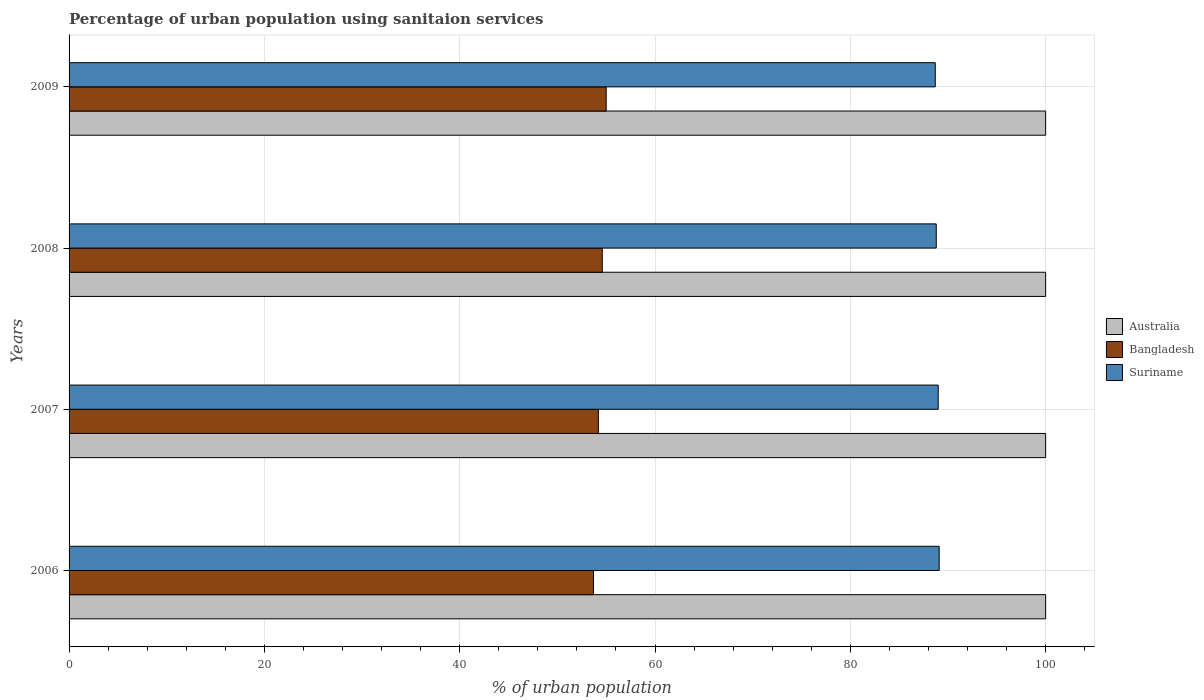How many bars are there on the 1st tick from the top?
Make the answer very short. 3. What is the label of the 4th group of bars from the top?
Offer a terse response. 2006. What is the percentage of urban population using sanitaion services in Bangladesh in 2007?
Offer a very short reply. 54.2. Across all years, what is the maximum percentage of urban population using sanitaion services in Suriname?
Give a very brief answer. 89.1. Across all years, what is the minimum percentage of urban population using sanitaion services in Australia?
Offer a terse response. 100. In which year was the percentage of urban population using sanitaion services in Suriname maximum?
Provide a short and direct response. 2006. In which year was the percentage of urban population using sanitaion services in Australia minimum?
Provide a short and direct response. 2006. What is the total percentage of urban population using sanitaion services in Bangladesh in the graph?
Offer a very short reply. 217.5. What is the difference between the percentage of urban population using sanitaion services in Australia in 2006 and the percentage of urban population using sanitaion services in Suriname in 2009?
Provide a short and direct response. 11.3. In the year 2008, what is the difference between the percentage of urban population using sanitaion services in Suriname and percentage of urban population using sanitaion services in Bangladesh?
Provide a short and direct response. 34.2. What is the ratio of the percentage of urban population using sanitaion services in Bangladesh in 2006 to that in 2007?
Your answer should be compact. 0.99. Is the difference between the percentage of urban population using sanitaion services in Suriname in 2008 and 2009 greater than the difference between the percentage of urban population using sanitaion services in Bangladesh in 2008 and 2009?
Your response must be concise. Yes. What is the difference between the highest and the second highest percentage of urban population using sanitaion services in Bangladesh?
Offer a terse response. 0.4. What is the difference between the highest and the lowest percentage of urban population using sanitaion services in Suriname?
Your response must be concise. 0.4. In how many years, is the percentage of urban population using sanitaion services in Bangladesh greater than the average percentage of urban population using sanitaion services in Bangladesh taken over all years?
Your answer should be compact. 2. What does the 3rd bar from the bottom in 2009 represents?
Offer a very short reply. Suriname. Is it the case that in every year, the sum of the percentage of urban population using sanitaion services in Australia and percentage of urban population using sanitaion services in Suriname is greater than the percentage of urban population using sanitaion services in Bangladesh?
Keep it short and to the point. Yes. How many bars are there?
Your response must be concise. 12. Are all the bars in the graph horizontal?
Offer a very short reply. Yes. Are the values on the major ticks of X-axis written in scientific E-notation?
Make the answer very short. No. Does the graph contain any zero values?
Make the answer very short. No. Where does the legend appear in the graph?
Make the answer very short. Center right. How many legend labels are there?
Offer a very short reply. 3. How are the legend labels stacked?
Your answer should be very brief. Vertical. What is the title of the graph?
Your response must be concise. Percentage of urban population using sanitaion services. Does "Arab World" appear as one of the legend labels in the graph?
Your response must be concise. No. What is the label or title of the X-axis?
Provide a succinct answer. % of urban population. What is the % of urban population of Bangladesh in 2006?
Make the answer very short. 53.7. What is the % of urban population in Suriname in 2006?
Keep it short and to the point. 89.1. What is the % of urban population in Bangladesh in 2007?
Offer a very short reply. 54.2. What is the % of urban population of Suriname in 2007?
Your answer should be compact. 89. What is the % of urban population in Bangladesh in 2008?
Offer a terse response. 54.6. What is the % of urban population of Suriname in 2008?
Your response must be concise. 88.8. What is the % of urban population of Bangladesh in 2009?
Your response must be concise. 55. What is the % of urban population of Suriname in 2009?
Offer a very short reply. 88.7. Across all years, what is the maximum % of urban population in Australia?
Ensure brevity in your answer.  100. Across all years, what is the maximum % of urban population in Bangladesh?
Give a very brief answer. 55. Across all years, what is the maximum % of urban population of Suriname?
Provide a succinct answer. 89.1. Across all years, what is the minimum % of urban population in Australia?
Your response must be concise. 100. Across all years, what is the minimum % of urban population of Bangladesh?
Keep it short and to the point. 53.7. Across all years, what is the minimum % of urban population of Suriname?
Your response must be concise. 88.7. What is the total % of urban population of Bangladesh in the graph?
Ensure brevity in your answer.  217.5. What is the total % of urban population of Suriname in the graph?
Give a very brief answer. 355.6. What is the difference between the % of urban population of Australia in 2006 and that in 2007?
Provide a short and direct response. 0. What is the difference between the % of urban population of Suriname in 2006 and that in 2007?
Offer a very short reply. 0.1. What is the difference between the % of urban population of Australia in 2006 and that in 2008?
Give a very brief answer. 0. What is the difference between the % of urban population in Bangladesh in 2006 and that in 2008?
Ensure brevity in your answer.  -0.9. What is the difference between the % of urban population of Suriname in 2006 and that in 2008?
Ensure brevity in your answer.  0.3. What is the difference between the % of urban population in Australia in 2006 and that in 2009?
Keep it short and to the point. 0. What is the difference between the % of urban population in Australia in 2007 and that in 2008?
Your response must be concise. 0. What is the difference between the % of urban population in Suriname in 2007 and that in 2009?
Offer a very short reply. 0.3. What is the difference between the % of urban population of Bangladesh in 2008 and that in 2009?
Give a very brief answer. -0.4. What is the difference between the % of urban population in Australia in 2006 and the % of urban population in Bangladesh in 2007?
Ensure brevity in your answer.  45.8. What is the difference between the % of urban population of Australia in 2006 and the % of urban population of Suriname in 2007?
Offer a terse response. 11. What is the difference between the % of urban population of Bangladesh in 2006 and the % of urban population of Suriname in 2007?
Give a very brief answer. -35.3. What is the difference between the % of urban population of Australia in 2006 and the % of urban population of Bangladesh in 2008?
Ensure brevity in your answer.  45.4. What is the difference between the % of urban population in Bangladesh in 2006 and the % of urban population in Suriname in 2008?
Ensure brevity in your answer.  -35.1. What is the difference between the % of urban population in Australia in 2006 and the % of urban population in Suriname in 2009?
Give a very brief answer. 11.3. What is the difference between the % of urban population in Bangladesh in 2006 and the % of urban population in Suriname in 2009?
Your answer should be compact. -35. What is the difference between the % of urban population in Australia in 2007 and the % of urban population in Bangladesh in 2008?
Keep it short and to the point. 45.4. What is the difference between the % of urban population in Bangladesh in 2007 and the % of urban population in Suriname in 2008?
Provide a short and direct response. -34.6. What is the difference between the % of urban population of Australia in 2007 and the % of urban population of Bangladesh in 2009?
Give a very brief answer. 45. What is the difference between the % of urban population of Bangladesh in 2007 and the % of urban population of Suriname in 2009?
Offer a terse response. -34.5. What is the difference between the % of urban population of Australia in 2008 and the % of urban population of Bangladesh in 2009?
Provide a short and direct response. 45. What is the difference between the % of urban population of Australia in 2008 and the % of urban population of Suriname in 2009?
Your answer should be very brief. 11.3. What is the difference between the % of urban population in Bangladesh in 2008 and the % of urban population in Suriname in 2009?
Offer a very short reply. -34.1. What is the average % of urban population in Bangladesh per year?
Your answer should be very brief. 54.38. What is the average % of urban population of Suriname per year?
Offer a terse response. 88.9. In the year 2006, what is the difference between the % of urban population of Australia and % of urban population of Bangladesh?
Give a very brief answer. 46.3. In the year 2006, what is the difference between the % of urban population in Bangladesh and % of urban population in Suriname?
Offer a terse response. -35.4. In the year 2007, what is the difference between the % of urban population of Australia and % of urban population of Bangladesh?
Give a very brief answer. 45.8. In the year 2007, what is the difference between the % of urban population of Bangladesh and % of urban population of Suriname?
Keep it short and to the point. -34.8. In the year 2008, what is the difference between the % of urban population of Australia and % of urban population of Bangladesh?
Provide a succinct answer. 45.4. In the year 2008, what is the difference between the % of urban population in Bangladesh and % of urban population in Suriname?
Offer a terse response. -34.2. In the year 2009, what is the difference between the % of urban population of Australia and % of urban population of Bangladesh?
Keep it short and to the point. 45. In the year 2009, what is the difference between the % of urban population of Bangladesh and % of urban population of Suriname?
Provide a succinct answer. -33.7. What is the ratio of the % of urban population in Bangladesh in 2006 to that in 2008?
Your response must be concise. 0.98. What is the ratio of the % of urban population of Bangladesh in 2006 to that in 2009?
Provide a succinct answer. 0.98. What is the ratio of the % of urban population of Suriname in 2006 to that in 2009?
Your response must be concise. 1. What is the ratio of the % of urban population of Suriname in 2007 to that in 2008?
Your answer should be very brief. 1. What is the ratio of the % of urban population of Bangladesh in 2007 to that in 2009?
Keep it short and to the point. 0.99. What is the ratio of the % of urban population in Australia in 2008 to that in 2009?
Your response must be concise. 1. What is the difference between the highest and the second highest % of urban population in Australia?
Your answer should be compact. 0. What is the difference between the highest and the lowest % of urban population of Australia?
Your answer should be compact. 0. 